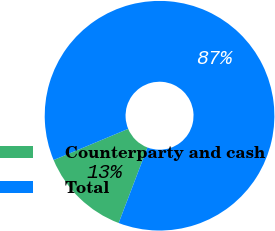Convert chart to OTSL. <chart><loc_0><loc_0><loc_500><loc_500><pie_chart><fcel>Counterparty and cash<fcel>Total<nl><fcel>12.9%<fcel>87.1%<nl></chart> 